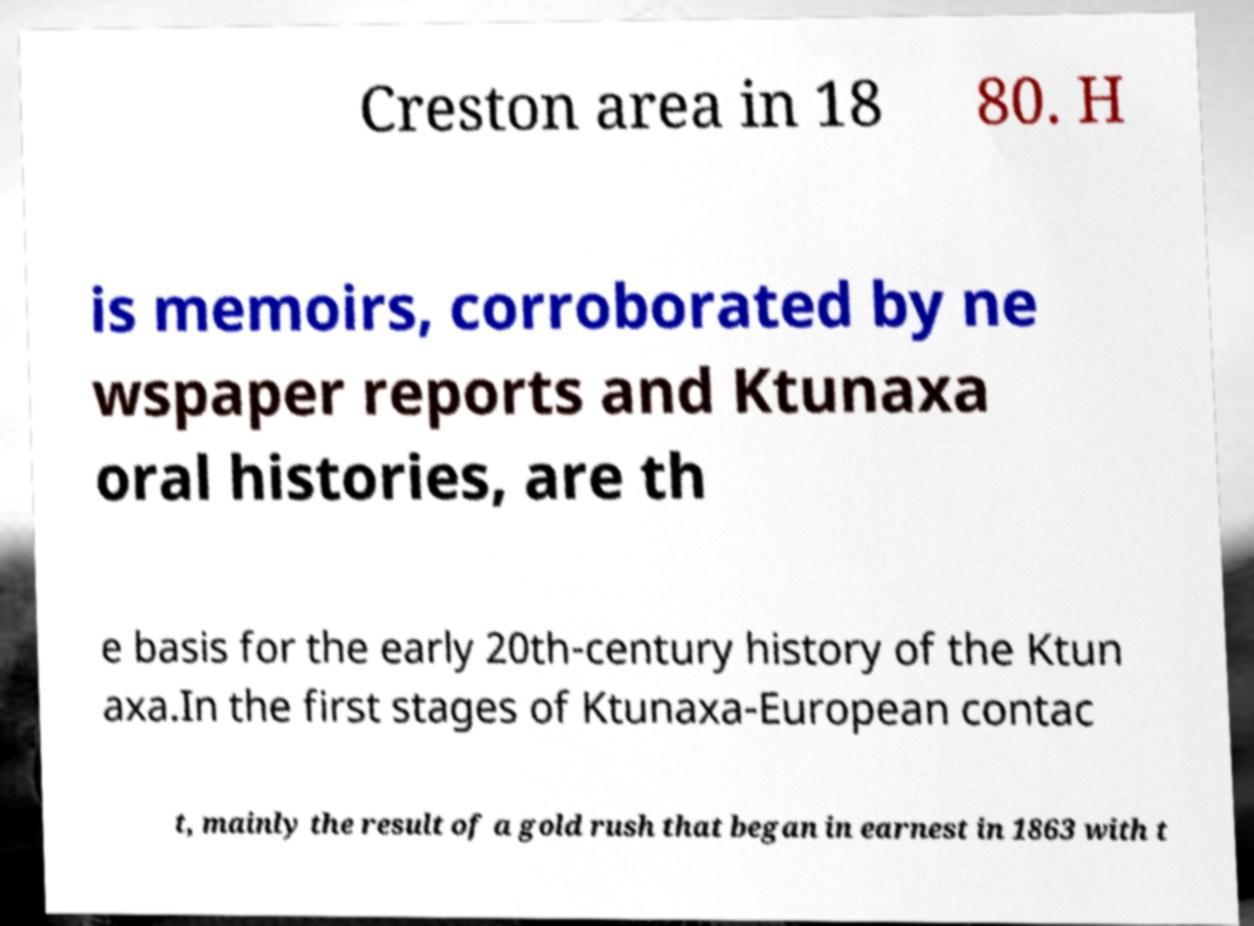Can you accurately transcribe the text from the provided image for me? Creston area in 18 80. H is memoirs, corroborated by ne wspaper reports and Ktunaxa oral histories, are th e basis for the early 20th-century history of the Ktun axa.In the first stages of Ktunaxa-European contac t, mainly the result of a gold rush that began in earnest in 1863 with t 